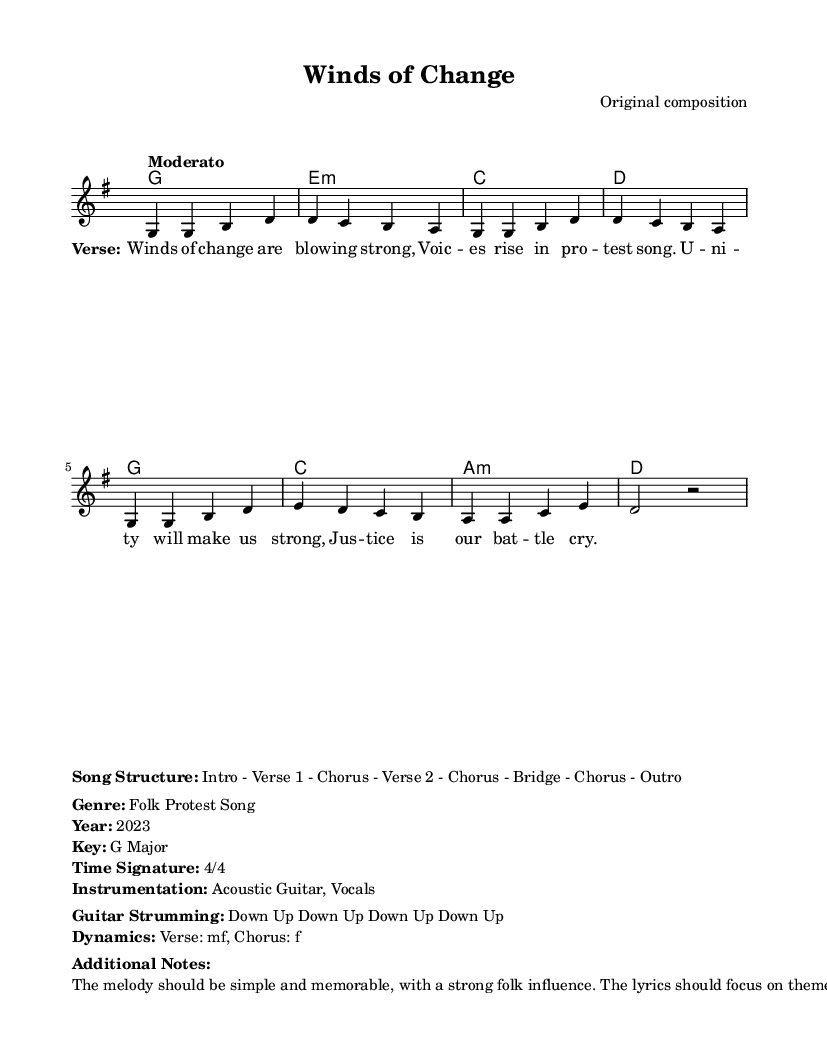What is the key signature of this music? The key signature is G major, which has one sharp (F#). This can be identified at the beginning of the sheet music where the key signature is indicated.
Answer: G major What is the time signature of the piece? The time signature is located at the beginning of the sheet music, indicating 4/4. This means there are four beats per measure and a quarter note receives one beat.
Answer: 4/4 What is the tempo marking for this music? The tempo marking reveals the speed of the piece, which is indicated as "Moderato." This term suggests a moderate pace, typically around 108-120 beats per minute.
Answer: Moderato How many verses are present in the song structure? By analyzing the song structure detailed in the markup, it states "Intro - Verse 1 - Chorus - Verse 2 - Chorus - Bridge - Chorus - Outro." There are two verses present.
Answer: 2 What instruments are specified in the instrumentation? The sheet music indicates "Acoustic Guitar, Vocals" in the instrumentation section. This means these two instruments are essential for performing the song as written.
Answer: Acoustic Guitar, Vocals What is the dynamic marking for the chorus? The dynamics are listed wherein it specifies "Verse: mf, Chorus: f." This indicates that the chorus should be played at a loud volume level (forte).
Answer: f What is the main theme of the lyrics according to the additional notes? The additional notes mention that the lyrics focus on "social change and unity," connecting the song to the intention behind the 1960s protest songs.
Answer: Social change and unity 